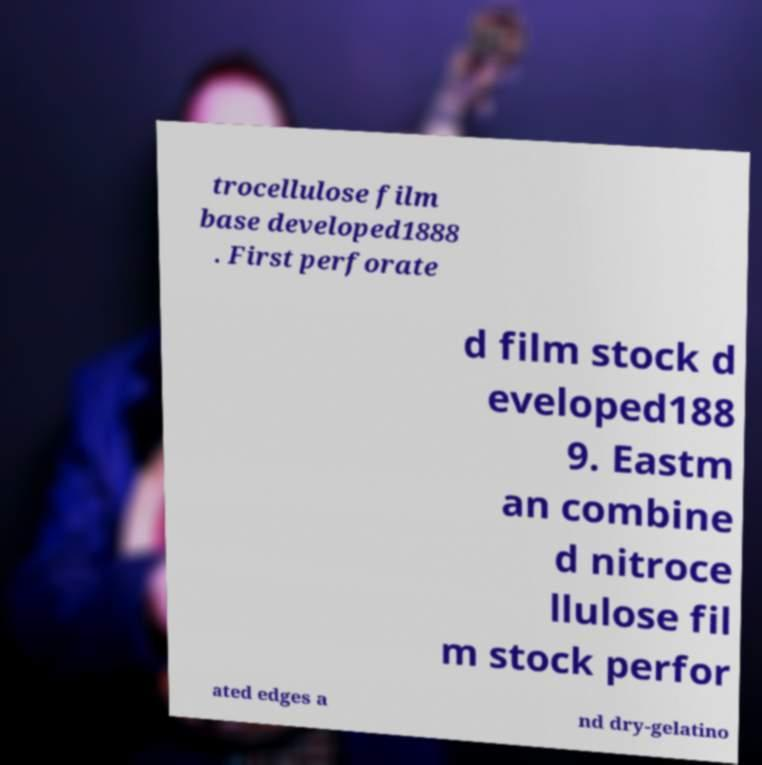There's text embedded in this image that I need extracted. Can you transcribe it verbatim? trocellulose film base developed1888 . First perforate d film stock d eveloped188 9. Eastm an combine d nitroce llulose fil m stock perfor ated edges a nd dry-gelatino 